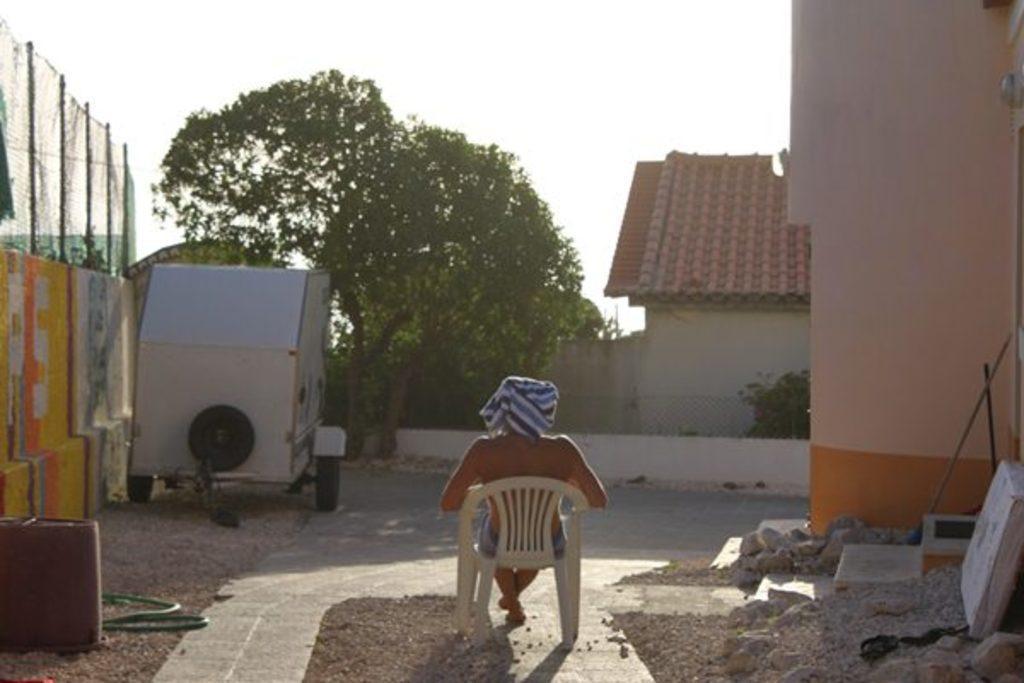In one or two sentences, can you explain what this image depicts? This picture shows a tree and a house and a person seated on a chair. we see a wall and a metal fence on it. 